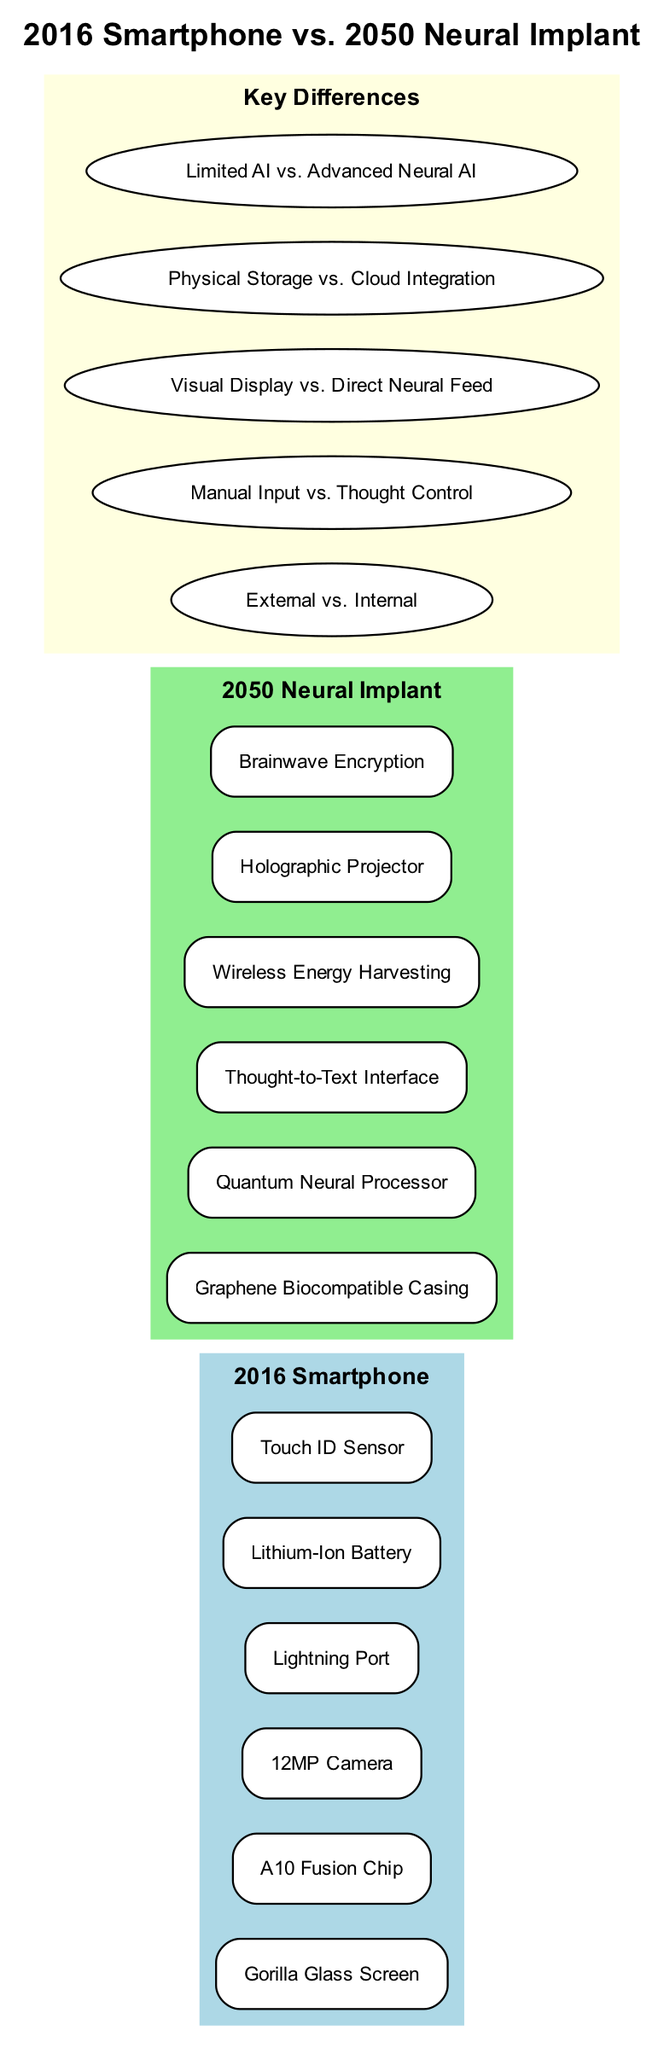What is the title of the diagram? The title is explicitly stated at the top of the diagram and is designed to convey the main comparison being discussed. It reads "2016 Smartphone vs. 2050 Neural Implant."
Answer: 2016 Smartphone vs. 2050 Neural Implant How many components are listed for the 2016 smartphone? The diagram lists six specific components under the "2016 Smartphone" section, which are directly visible in the box representing that section.
Answer: 6 What technology is used in the 2050 Neural Implant for processing? The component specifying the processing technology in the "2050 Neural Implant" section contains the precise term "Quantum Neural Processor." This indicates the advanced technology used in the implant.
Answer: Quantum Neural Processor What is one key difference between the two devices? The differences listed under the "Key Differences" section illustrate various aspects relating to the devices. One such difference states "External vs. Internal." This clarifies the nature of the devices being compared.
Answer: External vs. Internal Which component allows the 2050 Neural Implant to display images? The "Holographic Projector" listed in the 2050 Neural Implant section is specifically related to the capability of image projection, making it the correct answer to this question.
Answer: Holographic Projector What is the storage method mentioned for the 2016 smartphone? The diagram indicates "Physical Storage" as the storage method for the 2016 smartphone, contrasting with the methods of the 2050 device. This information is directly seen in the comparison section.
Answer: Physical Storage How do the input methods of the two devices differ? The comparison notes "Manual Input vs. Thought Control," explicitly outlining how the input methods diverge between the two devices, linking back to the operational differences.
Answer: Manual Input vs. Thought Control What is the material of the casing for the 2050 Neural Implant? In the components listed for the 2050 Neural Implant, the term "Graphene Biocompatible Casing" describes the advanced material used for its structure, showing its modern design and compatibility.
Answer: Graphene Biocompatible Casing How many key differences are highlighted in the diagram? The "Key Differences" section lists five distinct comparisons, highlighting the significant differences between the two devices. This number can be counted directly from the section.
Answer: 5 